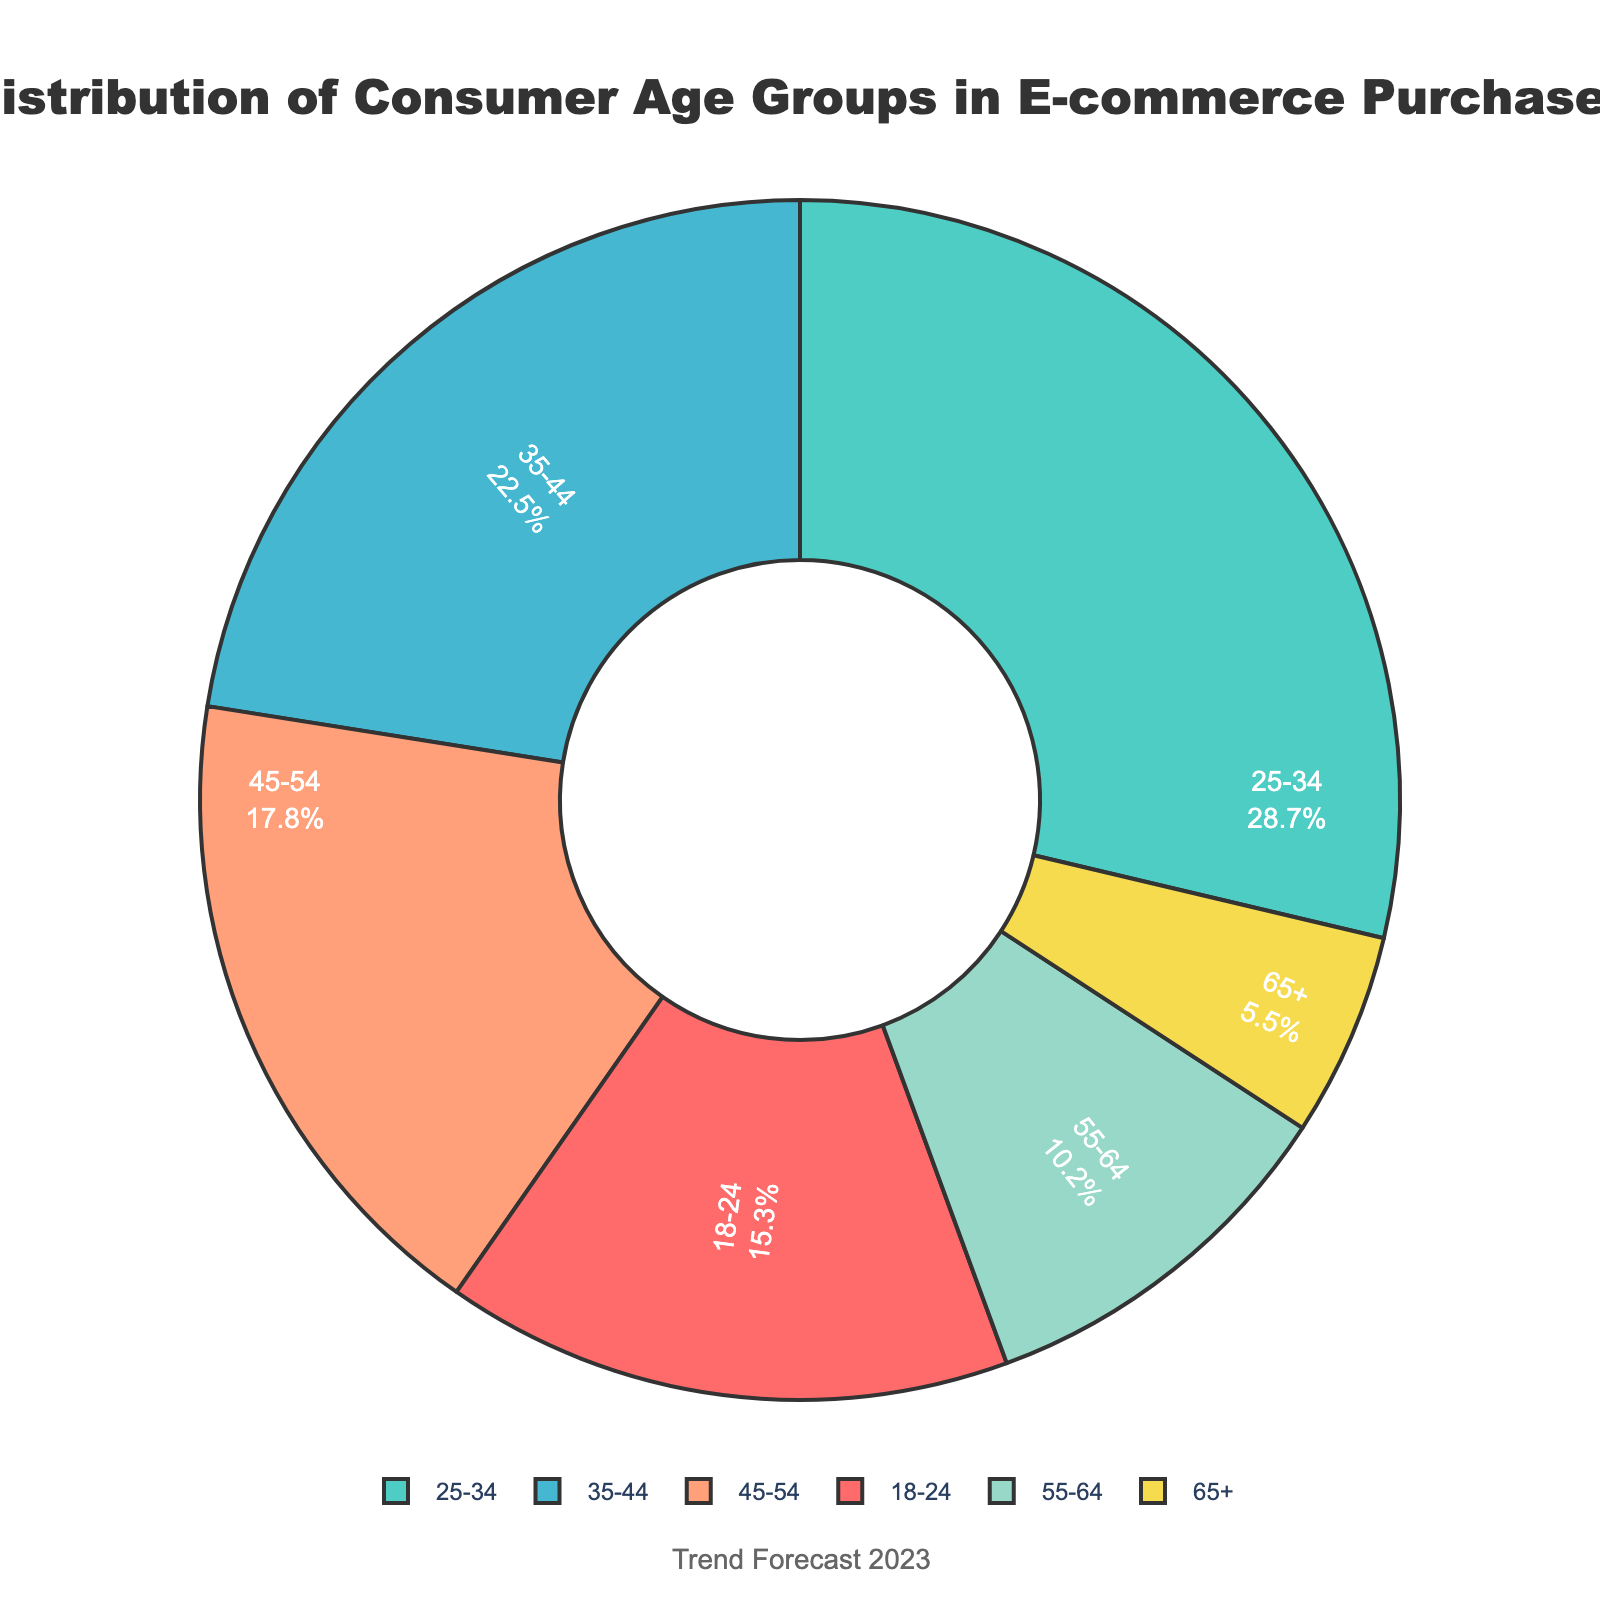What age group is the most dominant in e-commerce purchases? Observe the pie chart and locate the largest segment which is labeled "25-34" with a percentage representation of 28.7%
Answer: 25-34 Which age group has the smallest share and what is its percentage? Identify the smallest slice of the pie chart, which is labeled "65+" and represents 5.5% of the total
Answer: 65+, 5.5% How much larger in percentage is the 25-34 age group compared to the 65+ age group? The 25-34 age group is 28.7%, and the 65+ age group is 5.5%. Calculate the difference: 28.7% - 5.5% = 23.2%
Answer: 23.2% Which two consecutive age groups have the most similar percentages? Compare all consecutive age group percentages: (18-24: 15.3%, 25-34: 28.7%, 35-44: 22.5%, 45-54: 17.8%, 55-64: 10.2%, 65+: 5.5%). The closest are 18-24 (15.3%) and 45-54 (17.8%), with a difference of 2.5%
Answer: 18-24 and 45-54 What is the combined percentage of the age groups 35-44 and 45-54? Add the percentages of the 35-44 and 45-54 age groups: 22.5% + 17.8% = 40.3%
Answer: 40.3% Is the percentage of the 18-24 age group greater than the combined percentage of the 55-64 and 65+ age groups? Compare the percentage of the 18-24 age group (15.3%) with the sum of the 55-64 (10.2%) and 65+ (5.5%) age groups: 10.2% + 5.5% = 15.7%. Since 15.3% < 15.7%, the 18-24 age group is not greater
Answer: No Which age groups represent a larger share of e-commerce purchases than the 45-54 age group? The 45-54 age group is 17.8%. Any age groups with a larger share: 25-34 (28.7%), 35-44 (22.5%)
Answer: 25-34, 35-44 What color represents the 18-24 age group in the pie chart? Identify the 18-24 age group slice and observe its color, which is red (#FF6B6B)
Answer: Red 